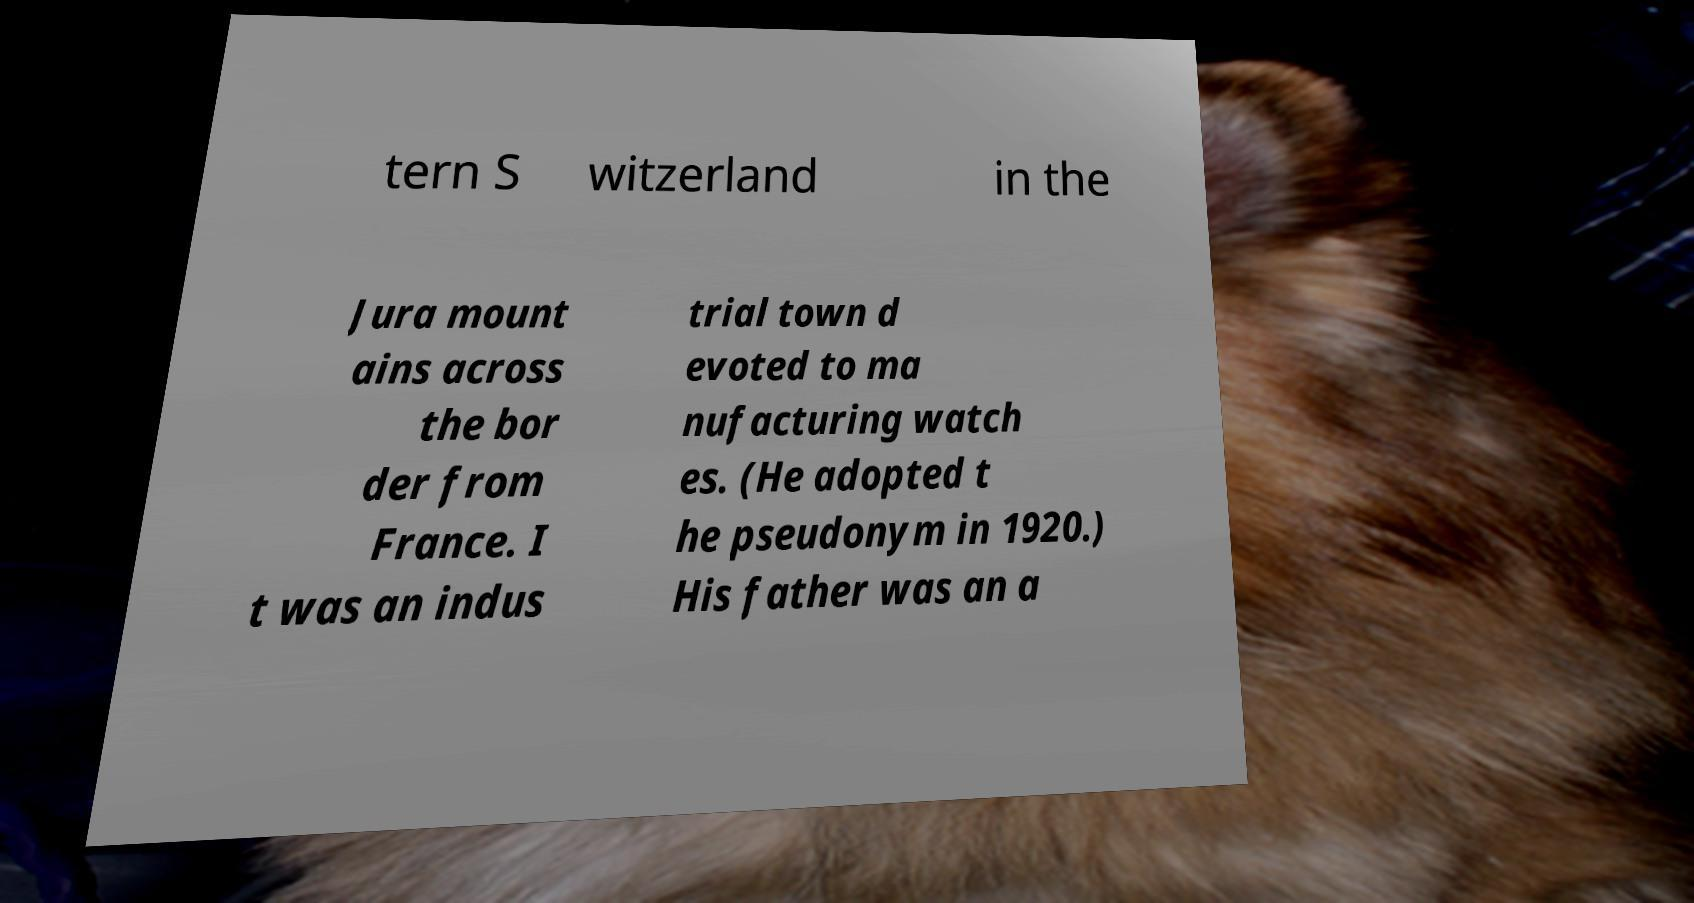Please identify and transcribe the text found in this image. tern S witzerland in the Jura mount ains across the bor der from France. I t was an indus trial town d evoted to ma nufacturing watch es. (He adopted t he pseudonym in 1920.) His father was an a 